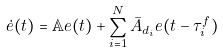<formula> <loc_0><loc_0><loc_500><loc_500>\dot { e } ( t ) = \mathbb { A } e ( t ) + \sum _ { i = 1 } ^ { N } \bar { A } _ { d _ { i } } e ( t - \tau _ { i } ^ { f } )</formula> 